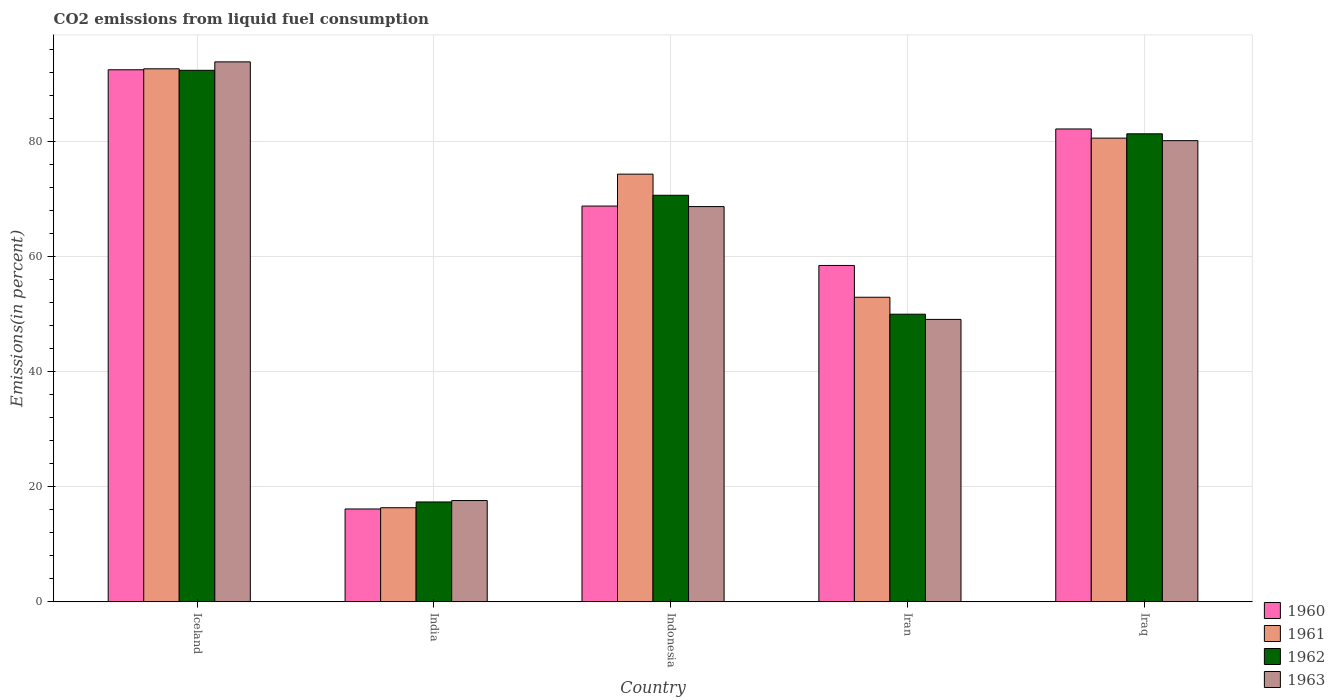How many different coloured bars are there?
Your answer should be compact. 4. How many groups of bars are there?
Ensure brevity in your answer.  5. How many bars are there on the 1st tick from the left?
Offer a very short reply. 4. How many bars are there on the 3rd tick from the right?
Provide a short and direct response. 4. What is the label of the 5th group of bars from the left?
Make the answer very short. Iraq. In how many cases, is the number of bars for a given country not equal to the number of legend labels?
Provide a short and direct response. 0. What is the total CO2 emitted in 1963 in Iran?
Keep it short and to the point. 49.08. Across all countries, what is the maximum total CO2 emitted in 1963?
Keep it short and to the point. 93.82. Across all countries, what is the minimum total CO2 emitted in 1963?
Offer a terse response. 17.61. In which country was the total CO2 emitted in 1963 minimum?
Your answer should be very brief. India. What is the total total CO2 emitted in 1962 in the graph?
Your answer should be very brief. 311.66. What is the difference between the total CO2 emitted in 1962 in India and that in Iran?
Provide a succinct answer. -32.62. What is the difference between the total CO2 emitted in 1960 in Iceland and the total CO2 emitted in 1963 in Iran?
Make the answer very short. 43.37. What is the average total CO2 emitted in 1962 per country?
Offer a terse response. 62.33. What is the difference between the total CO2 emitted of/in 1960 and total CO2 emitted of/in 1961 in Iceland?
Give a very brief answer. -0.17. In how many countries, is the total CO2 emitted in 1961 greater than 24 %?
Make the answer very short. 4. What is the ratio of the total CO2 emitted in 1962 in Iran to that in Iraq?
Your response must be concise. 0.61. Is the total CO2 emitted in 1962 in Indonesia less than that in Iran?
Your response must be concise. No. What is the difference between the highest and the second highest total CO2 emitted in 1963?
Make the answer very short. 11.45. What is the difference between the highest and the lowest total CO2 emitted in 1961?
Offer a terse response. 76.26. In how many countries, is the total CO2 emitted in 1963 greater than the average total CO2 emitted in 1963 taken over all countries?
Give a very brief answer. 3. Is it the case that in every country, the sum of the total CO2 emitted in 1962 and total CO2 emitted in 1963 is greater than the sum of total CO2 emitted in 1961 and total CO2 emitted in 1960?
Your answer should be compact. No. Is it the case that in every country, the sum of the total CO2 emitted in 1960 and total CO2 emitted in 1963 is greater than the total CO2 emitted in 1961?
Ensure brevity in your answer.  Yes. Are all the bars in the graph horizontal?
Ensure brevity in your answer.  No. How many countries are there in the graph?
Keep it short and to the point. 5. What is the difference between two consecutive major ticks on the Y-axis?
Offer a very short reply. 20. Are the values on the major ticks of Y-axis written in scientific E-notation?
Your answer should be very brief. No. Does the graph contain grids?
Give a very brief answer. Yes. How many legend labels are there?
Make the answer very short. 4. What is the title of the graph?
Keep it short and to the point. CO2 emissions from liquid fuel consumption. Does "1988" appear as one of the legend labels in the graph?
Keep it short and to the point. No. What is the label or title of the X-axis?
Offer a very short reply. Country. What is the label or title of the Y-axis?
Your response must be concise. Emissions(in percent). What is the Emissions(in percent) of 1960 in Iceland?
Give a very brief answer. 92.45. What is the Emissions(in percent) in 1961 in Iceland?
Keep it short and to the point. 92.62. What is the Emissions(in percent) of 1962 in Iceland?
Give a very brief answer. 92.35. What is the Emissions(in percent) of 1963 in Iceland?
Your answer should be compact. 93.82. What is the Emissions(in percent) in 1960 in India?
Your answer should be compact. 16.14. What is the Emissions(in percent) in 1961 in India?
Make the answer very short. 16.35. What is the Emissions(in percent) in 1962 in India?
Ensure brevity in your answer.  17.36. What is the Emissions(in percent) of 1963 in India?
Your answer should be very brief. 17.61. What is the Emissions(in percent) in 1960 in Indonesia?
Ensure brevity in your answer.  68.77. What is the Emissions(in percent) in 1961 in Indonesia?
Provide a succinct answer. 74.31. What is the Emissions(in percent) in 1962 in Indonesia?
Keep it short and to the point. 70.64. What is the Emissions(in percent) in 1963 in Indonesia?
Provide a succinct answer. 68.68. What is the Emissions(in percent) in 1960 in Iran?
Provide a succinct answer. 58.45. What is the Emissions(in percent) in 1961 in Iran?
Your answer should be very brief. 52.93. What is the Emissions(in percent) in 1962 in Iran?
Provide a succinct answer. 49.98. What is the Emissions(in percent) in 1963 in Iran?
Your answer should be compact. 49.08. What is the Emissions(in percent) of 1960 in Iraq?
Provide a succinct answer. 82.17. What is the Emissions(in percent) of 1961 in Iraq?
Your answer should be very brief. 80.57. What is the Emissions(in percent) in 1962 in Iraq?
Give a very brief answer. 81.32. What is the Emissions(in percent) of 1963 in Iraq?
Offer a terse response. 80.13. Across all countries, what is the maximum Emissions(in percent) of 1960?
Provide a short and direct response. 92.45. Across all countries, what is the maximum Emissions(in percent) in 1961?
Provide a short and direct response. 92.62. Across all countries, what is the maximum Emissions(in percent) in 1962?
Your response must be concise. 92.35. Across all countries, what is the maximum Emissions(in percent) in 1963?
Ensure brevity in your answer.  93.82. Across all countries, what is the minimum Emissions(in percent) in 1960?
Offer a very short reply. 16.14. Across all countries, what is the minimum Emissions(in percent) of 1961?
Your answer should be very brief. 16.35. Across all countries, what is the minimum Emissions(in percent) of 1962?
Give a very brief answer. 17.36. Across all countries, what is the minimum Emissions(in percent) in 1963?
Your response must be concise. 17.61. What is the total Emissions(in percent) in 1960 in the graph?
Your answer should be compact. 317.97. What is the total Emissions(in percent) in 1961 in the graph?
Offer a terse response. 316.78. What is the total Emissions(in percent) of 1962 in the graph?
Give a very brief answer. 311.66. What is the total Emissions(in percent) in 1963 in the graph?
Your response must be concise. 309.32. What is the difference between the Emissions(in percent) in 1960 in Iceland and that in India?
Provide a short and direct response. 76.31. What is the difference between the Emissions(in percent) of 1961 in Iceland and that in India?
Offer a terse response. 76.26. What is the difference between the Emissions(in percent) in 1962 in Iceland and that in India?
Make the answer very short. 74.99. What is the difference between the Emissions(in percent) of 1963 in Iceland and that in India?
Make the answer very short. 76.21. What is the difference between the Emissions(in percent) of 1960 in Iceland and that in Indonesia?
Offer a terse response. 23.68. What is the difference between the Emissions(in percent) of 1961 in Iceland and that in Indonesia?
Offer a very short reply. 18.3. What is the difference between the Emissions(in percent) in 1962 in Iceland and that in Indonesia?
Give a very brief answer. 21.71. What is the difference between the Emissions(in percent) in 1963 in Iceland and that in Indonesia?
Provide a short and direct response. 25.14. What is the difference between the Emissions(in percent) in 1960 in Iceland and that in Iran?
Ensure brevity in your answer.  34. What is the difference between the Emissions(in percent) in 1961 in Iceland and that in Iran?
Offer a very short reply. 39.69. What is the difference between the Emissions(in percent) of 1962 in Iceland and that in Iran?
Provide a short and direct response. 42.37. What is the difference between the Emissions(in percent) of 1963 in Iceland and that in Iran?
Your answer should be compact. 44.74. What is the difference between the Emissions(in percent) of 1960 in Iceland and that in Iraq?
Your answer should be compact. 10.28. What is the difference between the Emissions(in percent) in 1961 in Iceland and that in Iraq?
Ensure brevity in your answer.  12.05. What is the difference between the Emissions(in percent) in 1962 in Iceland and that in Iraq?
Provide a succinct answer. 11.03. What is the difference between the Emissions(in percent) in 1963 in Iceland and that in Iraq?
Give a very brief answer. 13.69. What is the difference between the Emissions(in percent) in 1960 in India and that in Indonesia?
Your answer should be compact. -52.63. What is the difference between the Emissions(in percent) in 1961 in India and that in Indonesia?
Make the answer very short. -57.96. What is the difference between the Emissions(in percent) of 1962 in India and that in Indonesia?
Your response must be concise. -53.28. What is the difference between the Emissions(in percent) in 1963 in India and that in Indonesia?
Your answer should be compact. -51.07. What is the difference between the Emissions(in percent) of 1960 in India and that in Iran?
Offer a very short reply. -42.31. What is the difference between the Emissions(in percent) in 1961 in India and that in Iran?
Provide a short and direct response. -36.57. What is the difference between the Emissions(in percent) of 1962 in India and that in Iran?
Make the answer very short. -32.62. What is the difference between the Emissions(in percent) in 1963 in India and that in Iran?
Ensure brevity in your answer.  -31.47. What is the difference between the Emissions(in percent) in 1960 in India and that in Iraq?
Offer a terse response. -66.03. What is the difference between the Emissions(in percent) in 1961 in India and that in Iraq?
Ensure brevity in your answer.  -64.22. What is the difference between the Emissions(in percent) of 1962 in India and that in Iraq?
Give a very brief answer. -63.96. What is the difference between the Emissions(in percent) in 1963 in India and that in Iraq?
Provide a succinct answer. -62.53. What is the difference between the Emissions(in percent) in 1960 in Indonesia and that in Iran?
Make the answer very short. 10.32. What is the difference between the Emissions(in percent) in 1961 in Indonesia and that in Iran?
Your answer should be very brief. 21.39. What is the difference between the Emissions(in percent) of 1962 in Indonesia and that in Iran?
Ensure brevity in your answer.  20.66. What is the difference between the Emissions(in percent) in 1963 in Indonesia and that in Iran?
Offer a very short reply. 19.6. What is the difference between the Emissions(in percent) in 1960 in Indonesia and that in Iraq?
Ensure brevity in your answer.  -13.4. What is the difference between the Emissions(in percent) in 1961 in Indonesia and that in Iraq?
Your answer should be compact. -6.26. What is the difference between the Emissions(in percent) of 1962 in Indonesia and that in Iraq?
Provide a short and direct response. -10.68. What is the difference between the Emissions(in percent) of 1963 in Indonesia and that in Iraq?
Provide a succinct answer. -11.45. What is the difference between the Emissions(in percent) in 1960 in Iran and that in Iraq?
Offer a very short reply. -23.72. What is the difference between the Emissions(in percent) of 1961 in Iran and that in Iraq?
Provide a succinct answer. -27.65. What is the difference between the Emissions(in percent) in 1962 in Iran and that in Iraq?
Provide a succinct answer. -31.34. What is the difference between the Emissions(in percent) in 1963 in Iran and that in Iraq?
Offer a very short reply. -31.06. What is the difference between the Emissions(in percent) in 1960 in Iceland and the Emissions(in percent) in 1961 in India?
Make the answer very short. 76.09. What is the difference between the Emissions(in percent) of 1960 in Iceland and the Emissions(in percent) of 1962 in India?
Keep it short and to the point. 75.09. What is the difference between the Emissions(in percent) of 1960 in Iceland and the Emissions(in percent) of 1963 in India?
Ensure brevity in your answer.  74.84. What is the difference between the Emissions(in percent) of 1961 in Iceland and the Emissions(in percent) of 1962 in India?
Provide a succinct answer. 75.26. What is the difference between the Emissions(in percent) in 1961 in Iceland and the Emissions(in percent) in 1963 in India?
Your answer should be compact. 75.01. What is the difference between the Emissions(in percent) of 1962 in Iceland and the Emissions(in percent) of 1963 in India?
Your answer should be very brief. 74.75. What is the difference between the Emissions(in percent) of 1960 in Iceland and the Emissions(in percent) of 1961 in Indonesia?
Keep it short and to the point. 18.13. What is the difference between the Emissions(in percent) in 1960 in Iceland and the Emissions(in percent) in 1962 in Indonesia?
Your answer should be compact. 21.8. What is the difference between the Emissions(in percent) of 1960 in Iceland and the Emissions(in percent) of 1963 in Indonesia?
Provide a succinct answer. 23.77. What is the difference between the Emissions(in percent) of 1961 in Iceland and the Emissions(in percent) of 1962 in Indonesia?
Your answer should be very brief. 21.97. What is the difference between the Emissions(in percent) of 1961 in Iceland and the Emissions(in percent) of 1963 in Indonesia?
Your answer should be very brief. 23.94. What is the difference between the Emissions(in percent) in 1962 in Iceland and the Emissions(in percent) in 1963 in Indonesia?
Give a very brief answer. 23.68. What is the difference between the Emissions(in percent) of 1960 in Iceland and the Emissions(in percent) of 1961 in Iran?
Your answer should be compact. 39.52. What is the difference between the Emissions(in percent) of 1960 in Iceland and the Emissions(in percent) of 1962 in Iran?
Ensure brevity in your answer.  42.47. What is the difference between the Emissions(in percent) of 1960 in Iceland and the Emissions(in percent) of 1963 in Iran?
Provide a short and direct response. 43.37. What is the difference between the Emissions(in percent) of 1961 in Iceland and the Emissions(in percent) of 1962 in Iran?
Give a very brief answer. 42.64. What is the difference between the Emissions(in percent) of 1961 in Iceland and the Emissions(in percent) of 1963 in Iran?
Offer a very short reply. 43.54. What is the difference between the Emissions(in percent) in 1962 in Iceland and the Emissions(in percent) in 1963 in Iran?
Your response must be concise. 43.28. What is the difference between the Emissions(in percent) of 1960 in Iceland and the Emissions(in percent) of 1961 in Iraq?
Give a very brief answer. 11.88. What is the difference between the Emissions(in percent) of 1960 in Iceland and the Emissions(in percent) of 1962 in Iraq?
Offer a terse response. 11.12. What is the difference between the Emissions(in percent) of 1960 in Iceland and the Emissions(in percent) of 1963 in Iraq?
Ensure brevity in your answer.  12.31. What is the difference between the Emissions(in percent) in 1961 in Iceland and the Emissions(in percent) in 1962 in Iraq?
Your response must be concise. 11.29. What is the difference between the Emissions(in percent) of 1961 in Iceland and the Emissions(in percent) of 1963 in Iraq?
Your answer should be compact. 12.48. What is the difference between the Emissions(in percent) in 1962 in Iceland and the Emissions(in percent) in 1963 in Iraq?
Offer a very short reply. 12.22. What is the difference between the Emissions(in percent) in 1960 in India and the Emissions(in percent) in 1961 in Indonesia?
Offer a terse response. -58.17. What is the difference between the Emissions(in percent) in 1960 in India and the Emissions(in percent) in 1962 in Indonesia?
Make the answer very short. -54.5. What is the difference between the Emissions(in percent) in 1960 in India and the Emissions(in percent) in 1963 in Indonesia?
Your answer should be compact. -52.54. What is the difference between the Emissions(in percent) in 1961 in India and the Emissions(in percent) in 1962 in Indonesia?
Give a very brief answer. -54.29. What is the difference between the Emissions(in percent) of 1961 in India and the Emissions(in percent) of 1963 in Indonesia?
Ensure brevity in your answer.  -52.32. What is the difference between the Emissions(in percent) of 1962 in India and the Emissions(in percent) of 1963 in Indonesia?
Your answer should be very brief. -51.32. What is the difference between the Emissions(in percent) of 1960 in India and the Emissions(in percent) of 1961 in Iran?
Provide a short and direct response. -36.79. What is the difference between the Emissions(in percent) of 1960 in India and the Emissions(in percent) of 1962 in Iran?
Ensure brevity in your answer.  -33.84. What is the difference between the Emissions(in percent) of 1960 in India and the Emissions(in percent) of 1963 in Iran?
Your answer should be very brief. -32.94. What is the difference between the Emissions(in percent) of 1961 in India and the Emissions(in percent) of 1962 in Iran?
Your answer should be compact. -33.63. What is the difference between the Emissions(in percent) of 1961 in India and the Emissions(in percent) of 1963 in Iran?
Your response must be concise. -32.72. What is the difference between the Emissions(in percent) of 1962 in India and the Emissions(in percent) of 1963 in Iran?
Your answer should be very brief. -31.72. What is the difference between the Emissions(in percent) in 1960 in India and the Emissions(in percent) in 1961 in Iraq?
Offer a very short reply. -64.43. What is the difference between the Emissions(in percent) of 1960 in India and the Emissions(in percent) of 1962 in Iraq?
Provide a succinct answer. -65.18. What is the difference between the Emissions(in percent) of 1960 in India and the Emissions(in percent) of 1963 in Iraq?
Make the answer very short. -63.99. What is the difference between the Emissions(in percent) in 1961 in India and the Emissions(in percent) in 1962 in Iraq?
Provide a succinct answer. -64.97. What is the difference between the Emissions(in percent) in 1961 in India and the Emissions(in percent) in 1963 in Iraq?
Your answer should be very brief. -63.78. What is the difference between the Emissions(in percent) of 1962 in India and the Emissions(in percent) of 1963 in Iraq?
Your response must be concise. -62.77. What is the difference between the Emissions(in percent) in 1960 in Indonesia and the Emissions(in percent) in 1961 in Iran?
Offer a very short reply. 15.84. What is the difference between the Emissions(in percent) in 1960 in Indonesia and the Emissions(in percent) in 1962 in Iran?
Offer a terse response. 18.79. What is the difference between the Emissions(in percent) in 1960 in Indonesia and the Emissions(in percent) in 1963 in Iran?
Provide a short and direct response. 19.69. What is the difference between the Emissions(in percent) in 1961 in Indonesia and the Emissions(in percent) in 1962 in Iran?
Keep it short and to the point. 24.33. What is the difference between the Emissions(in percent) of 1961 in Indonesia and the Emissions(in percent) of 1963 in Iran?
Ensure brevity in your answer.  25.24. What is the difference between the Emissions(in percent) of 1962 in Indonesia and the Emissions(in percent) of 1963 in Iran?
Provide a succinct answer. 21.57. What is the difference between the Emissions(in percent) in 1960 in Indonesia and the Emissions(in percent) in 1961 in Iraq?
Offer a terse response. -11.8. What is the difference between the Emissions(in percent) of 1960 in Indonesia and the Emissions(in percent) of 1962 in Iraq?
Provide a short and direct response. -12.56. What is the difference between the Emissions(in percent) of 1960 in Indonesia and the Emissions(in percent) of 1963 in Iraq?
Keep it short and to the point. -11.36. What is the difference between the Emissions(in percent) in 1961 in Indonesia and the Emissions(in percent) in 1962 in Iraq?
Give a very brief answer. -7.01. What is the difference between the Emissions(in percent) in 1961 in Indonesia and the Emissions(in percent) in 1963 in Iraq?
Make the answer very short. -5.82. What is the difference between the Emissions(in percent) of 1962 in Indonesia and the Emissions(in percent) of 1963 in Iraq?
Make the answer very short. -9.49. What is the difference between the Emissions(in percent) in 1960 in Iran and the Emissions(in percent) in 1961 in Iraq?
Make the answer very short. -22.12. What is the difference between the Emissions(in percent) of 1960 in Iran and the Emissions(in percent) of 1962 in Iraq?
Give a very brief answer. -22.88. What is the difference between the Emissions(in percent) in 1960 in Iran and the Emissions(in percent) in 1963 in Iraq?
Give a very brief answer. -21.68. What is the difference between the Emissions(in percent) of 1961 in Iran and the Emissions(in percent) of 1962 in Iraq?
Offer a terse response. -28.4. What is the difference between the Emissions(in percent) in 1961 in Iran and the Emissions(in percent) in 1963 in Iraq?
Make the answer very short. -27.21. What is the difference between the Emissions(in percent) of 1962 in Iran and the Emissions(in percent) of 1963 in Iraq?
Provide a succinct answer. -30.15. What is the average Emissions(in percent) in 1960 per country?
Make the answer very short. 63.59. What is the average Emissions(in percent) of 1961 per country?
Offer a very short reply. 63.36. What is the average Emissions(in percent) of 1962 per country?
Offer a very short reply. 62.33. What is the average Emissions(in percent) in 1963 per country?
Provide a succinct answer. 61.86. What is the difference between the Emissions(in percent) of 1960 and Emissions(in percent) of 1961 in Iceland?
Keep it short and to the point. -0.17. What is the difference between the Emissions(in percent) of 1960 and Emissions(in percent) of 1962 in Iceland?
Give a very brief answer. 0.09. What is the difference between the Emissions(in percent) in 1960 and Emissions(in percent) in 1963 in Iceland?
Keep it short and to the point. -1.37. What is the difference between the Emissions(in percent) of 1961 and Emissions(in percent) of 1962 in Iceland?
Keep it short and to the point. 0.26. What is the difference between the Emissions(in percent) of 1961 and Emissions(in percent) of 1963 in Iceland?
Provide a succinct answer. -1.2. What is the difference between the Emissions(in percent) in 1962 and Emissions(in percent) in 1963 in Iceland?
Give a very brief answer. -1.47. What is the difference between the Emissions(in percent) in 1960 and Emissions(in percent) in 1961 in India?
Ensure brevity in your answer.  -0.22. What is the difference between the Emissions(in percent) of 1960 and Emissions(in percent) of 1962 in India?
Keep it short and to the point. -1.22. What is the difference between the Emissions(in percent) in 1960 and Emissions(in percent) in 1963 in India?
Provide a short and direct response. -1.47. What is the difference between the Emissions(in percent) in 1961 and Emissions(in percent) in 1962 in India?
Your answer should be compact. -1.01. What is the difference between the Emissions(in percent) in 1961 and Emissions(in percent) in 1963 in India?
Your answer should be compact. -1.25. What is the difference between the Emissions(in percent) in 1962 and Emissions(in percent) in 1963 in India?
Provide a succinct answer. -0.25. What is the difference between the Emissions(in percent) of 1960 and Emissions(in percent) of 1961 in Indonesia?
Ensure brevity in your answer.  -5.54. What is the difference between the Emissions(in percent) of 1960 and Emissions(in percent) of 1962 in Indonesia?
Offer a terse response. -1.87. What is the difference between the Emissions(in percent) of 1960 and Emissions(in percent) of 1963 in Indonesia?
Offer a terse response. 0.09. What is the difference between the Emissions(in percent) in 1961 and Emissions(in percent) in 1962 in Indonesia?
Provide a succinct answer. 3.67. What is the difference between the Emissions(in percent) of 1961 and Emissions(in percent) of 1963 in Indonesia?
Ensure brevity in your answer.  5.63. What is the difference between the Emissions(in percent) in 1962 and Emissions(in percent) in 1963 in Indonesia?
Your response must be concise. 1.96. What is the difference between the Emissions(in percent) of 1960 and Emissions(in percent) of 1961 in Iran?
Offer a very short reply. 5.52. What is the difference between the Emissions(in percent) of 1960 and Emissions(in percent) of 1962 in Iran?
Make the answer very short. 8.47. What is the difference between the Emissions(in percent) of 1960 and Emissions(in percent) of 1963 in Iran?
Your response must be concise. 9.37. What is the difference between the Emissions(in percent) of 1961 and Emissions(in percent) of 1962 in Iran?
Your response must be concise. 2.94. What is the difference between the Emissions(in percent) in 1961 and Emissions(in percent) in 1963 in Iran?
Provide a succinct answer. 3.85. What is the difference between the Emissions(in percent) of 1962 and Emissions(in percent) of 1963 in Iran?
Your response must be concise. 0.9. What is the difference between the Emissions(in percent) of 1960 and Emissions(in percent) of 1961 in Iraq?
Ensure brevity in your answer.  1.59. What is the difference between the Emissions(in percent) in 1960 and Emissions(in percent) in 1962 in Iraq?
Keep it short and to the point. 0.84. What is the difference between the Emissions(in percent) of 1960 and Emissions(in percent) of 1963 in Iraq?
Give a very brief answer. 2.03. What is the difference between the Emissions(in percent) of 1961 and Emissions(in percent) of 1962 in Iraq?
Make the answer very short. -0.75. What is the difference between the Emissions(in percent) of 1961 and Emissions(in percent) of 1963 in Iraq?
Make the answer very short. 0.44. What is the difference between the Emissions(in percent) of 1962 and Emissions(in percent) of 1963 in Iraq?
Offer a very short reply. 1.19. What is the ratio of the Emissions(in percent) of 1960 in Iceland to that in India?
Your response must be concise. 5.73. What is the ratio of the Emissions(in percent) of 1961 in Iceland to that in India?
Your answer should be compact. 5.66. What is the ratio of the Emissions(in percent) in 1962 in Iceland to that in India?
Keep it short and to the point. 5.32. What is the ratio of the Emissions(in percent) in 1963 in Iceland to that in India?
Keep it short and to the point. 5.33. What is the ratio of the Emissions(in percent) of 1960 in Iceland to that in Indonesia?
Ensure brevity in your answer.  1.34. What is the ratio of the Emissions(in percent) in 1961 in Iceland to that in Indonesia?
Offer a terse response. 1.25. What is the ratio of the Emissions(in percent) of 1962 in Iceland to that in Indonesia?
Offer a very short reply. 1.31. What is the ratio of the Emissions(in percent) of 1963 in Iceland to that in Indonesia?
Provide a short and direct response. 1.37. What is the ratio of the Emissions(in percent) in 1960 in Iceland to that in Iran?
Your response must be concise. 1.58. What is the ratio of the Emissions(in percent) in 1962 in Iceland to that in Iran?
Provide a succinct answer. 1.85. What is the ratio of the Emissions(in percent) of 1963 in Iceland to that in Iran?
Provide a short and direct response. 1.91. What is the ratio of the Emissions(in percent) in 1960 in Iceland to that in Iraq?
Give a very brief answer. 1.13. What is the ratio of the Emissions(in percent) of 1961 in Iceland to that in Iraq?
Ensure brevity in your answer.  1.15. What is the ratio of the Emissions(in percent) of 1962 in Iceland to that in Iraq?
Your response must be concise. 1.14. What is the ratio of the Emissions(in percent) in 1963 in Iceland to that in Iraq?
Ensure brevity in your answer.  1.17. What is the ratio of the Emissions(in percent) of 1960 in India to that in Indonesia?
Your answer should be very brief. 0.23. What is the ratio of the Emissions(in percent) in 1961 in India to that in Indonesia?
Your answer should be compact. 0.22. What is the ratio of the Emissions(in percent) of 1962 in India to that in Indonesia?
Provide a succinct answer. 0.25. What is the ratio of the Emissions(in percent) of 1963 in India to that in Indonesia?
Keep it short and to the point. 0.26. What is the ratio of the Emissions(in percent) in 1960 in India to that in Iran?
Your answer should be very brief. 0.28. What is the ratio of the Emissions(in percent) in 1961 in India to that in Iran?
Your answer should be very brief. 0.31. What is the ratio of the Emissions(in percent) in 1962 in India to that in Iran?
Give a very brief answer. 0.35. What is the ratio of the Emissions(in percent) in 1963 in India to that in Iran?
Offer a very short reply. 0.36. What is the ratio of the Emissions(in percent) of 1960 in India to that in Iraq?
Offer a terse response. 0.2. What is the ratio of the Emissions(in percent) of 1961 in India to that in Iraq?
Give a very brief answer. 0.2. What is the ratio of the Emissions(in percent) of 1962 in India to that in Iraq?
Your answer should be compact. 0.21. What is the ratio of the Emissions(in percent) of 1963 in India to that in Iraq?
Keep it short and to the point. 0.22. What is the ratio of the Emissions(in percent) in 1960 in Indonesia to that in Iran?
Ensure brevity in your answer.  1.18. What is the ratio of the Emissions(in percent) in 1961 in Indonesia to that in Iran?
Your answer should be compact. 1.4. What is the ratio of the Emissions(in percent) in 1962 in Indonesia to that in Iran?
Provide a short and direct response. 1.41. What is the ratio of the Emissions(in percent) of 1963 in Indonesia to that in Iran?
Your response must be concise. 1.4. What is the ratio of the Emissions(in percent) in 1960 in Indonesia to that in Iraq?
Provide a short and direct response. 0.84. What is the ratio of the Emissions(in percent) in 1961 in Indonesia to that in Iraq?
Your answer should be very brief. 0.92. What is the ratio of the Emissions(in percent) in 1962 in Indonesia to that in Iraq?
Provide a short and direct response. 0.87. What is the ratio of the Emissions(in percent) in 1960 in Iran to that in Iraq?
Your answer should be very brief. 0.71. What is the ratio of the Emissions(in percent) of 1961 in Iran to that in Iraq?
Your answer should be very brief. 0.66. What is the ratio of the Emissions(in percent) of 1962 in Iran to that in Iraq?
Offer a very short reply. 0.61. What is the ratio of the Emissions(in percent) of 1963 in Iran to that in Iraq?
Ensure brevity in your answer.  0.61. What is the difference between the highest and the second highest Emissions(in percent) in 1960?
Provide a short and direct response. 10.28. What is the difference between the highest and the second highest Emissions(in percent) of 1961?
Offer a very short reply. 12.05. What is the difference between the highest and the second highest Emissions(in percent) of 1962?
Give a very brief answer. 11.03. What is the difference between the highest and the second highest Emissions(in percent) in 1963?
Your answer should be compact. 13.69. What is the difference between the highest and the lowest Emissions(in percent) of 1960?
Ensure brevity in your answer.  76.31. What is the difference between the highest and the lowest Emissions(in percent) in 1961?
Your answer should be very brief. 76.26. What is the difference between the highest and the lowest Emissions(in percent) of 1962?
Ensure brevity in your answer.  74.99. What is the difference between the highest and the lowest Emissions(in percent) of 1963?
Offer a very short reply. 76.21. 